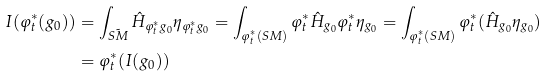<formula> <loc_0><loc_0><loc_500><loc_500>I ( \varphi _ { t } ^ { * } ( g _ { 0 } ) ) & = \int _ { \tilde { S M } } \hat { H } _ { \varphi _ { t } ^ { * } g _ { 0 } } \eta _ { \varphi _ { t } ^ { * } g _ { 0 } } = \int _ { \varphi _ { t } ^ { * } ( S M ) } \varphi _ { t } ^ { * } \hat { H } _ { g _ { 0 } } \varphi _ { t } ^ { * } \eta _ { g _ { 0 } } = \int _ { \varphi _ { t } ^ { * } ( S M ) } \varphi _ { t } ^ { * } ( \hat { H } _ { g _ { 0 } } \eta _ { g _ { 0 } } ) \\ & = \varphi _ { t } ^ { * } ( I ( g _ { 0 } ) )</formula> 